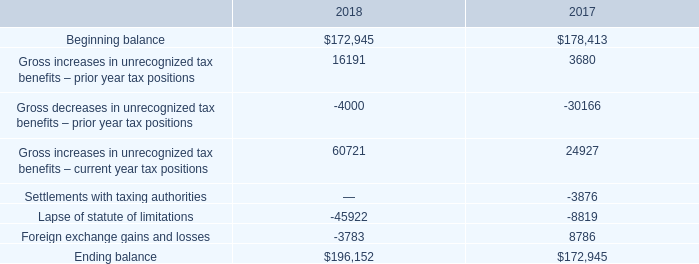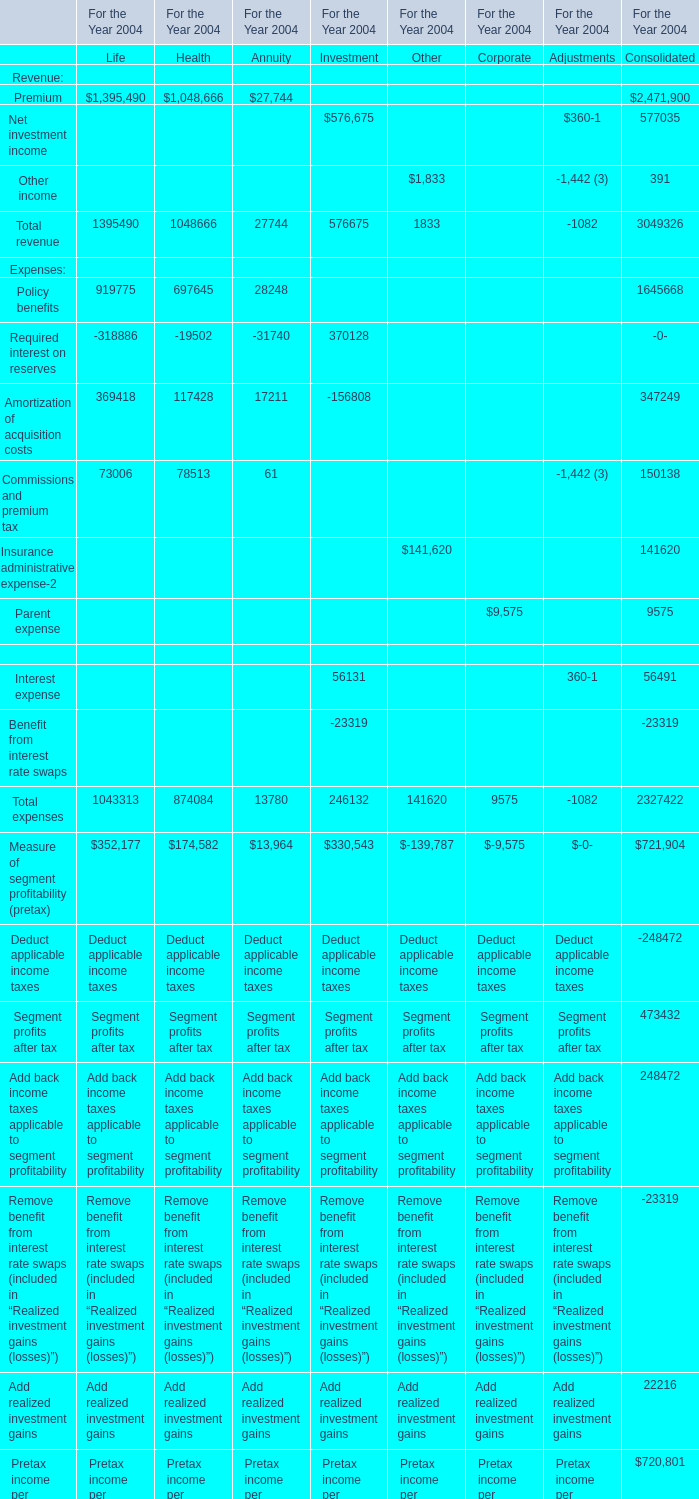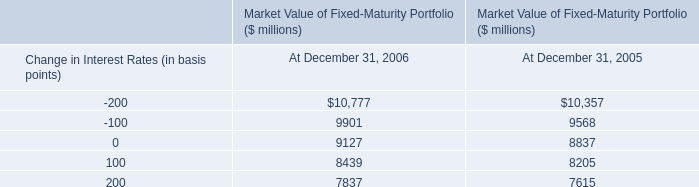What is the average amount of Other income of For the Year 2004 Other, and Lapse of statute of limitations of 2017 ? 
Computations: ((1833.0 + 8819.0) / 2)
Answer: 5326.0. 